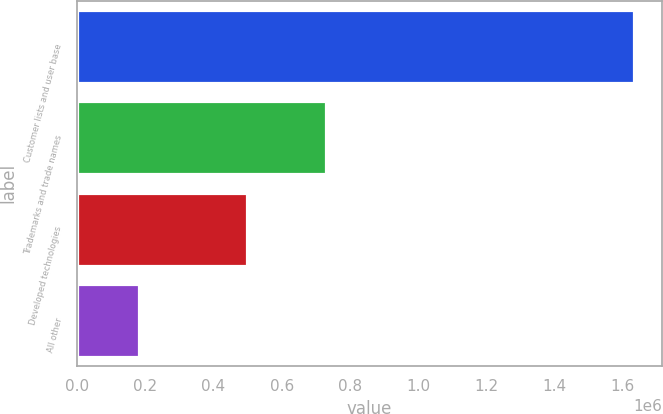<chart> <loc_0><loc_0><loc_500><loc_500><bar_chart><fcel>Customer lists and user base<fcel>Trademarks and trade names<fcel>Developed technologies<fcel>All other<nl><fcel>1.63342e+06<fcel>729907<fcel>497883<fcel>181755<nl></chart> 